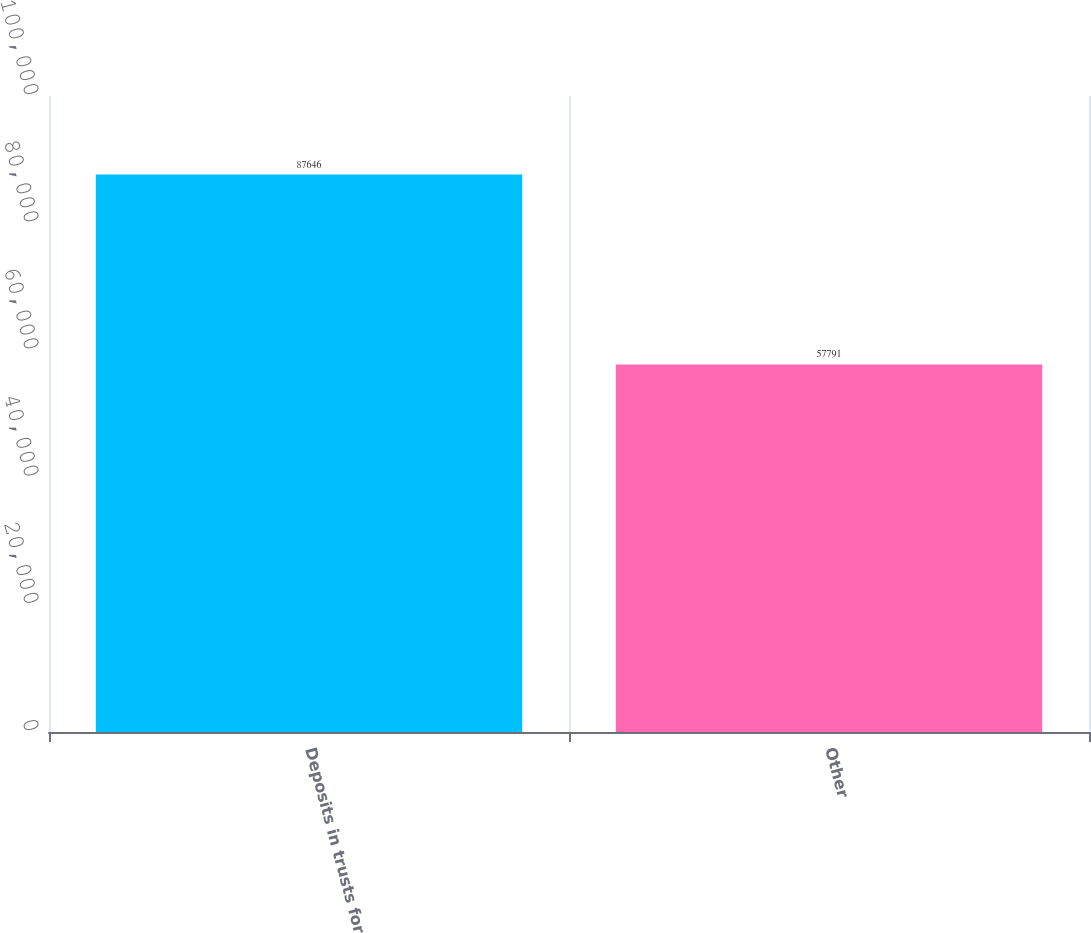Convert chart to OTSL. <chart><loc_0><loc_0><loc_500><loc_500><bar_chart><fcel>Deposits in trusts for<fcel>Other<nl><fcel>87646<fcel>57791<nl></chart> 